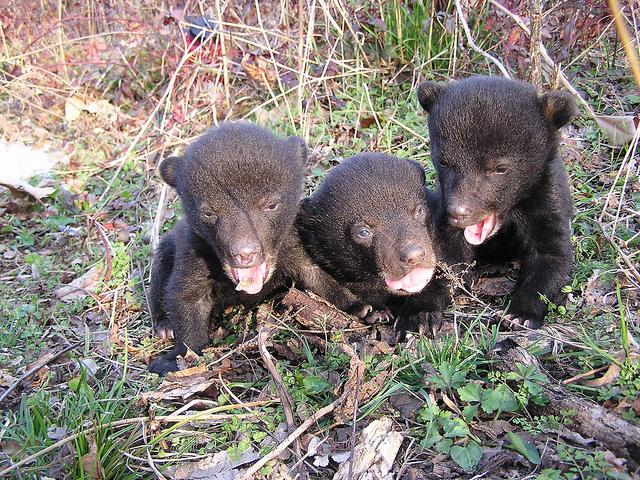Are these animals full grown?
Short answer required. No. Are they likely to meet Goldilocks soon?
Be succinct. No. What variety of bear are these?
Quick response, please. Black. 